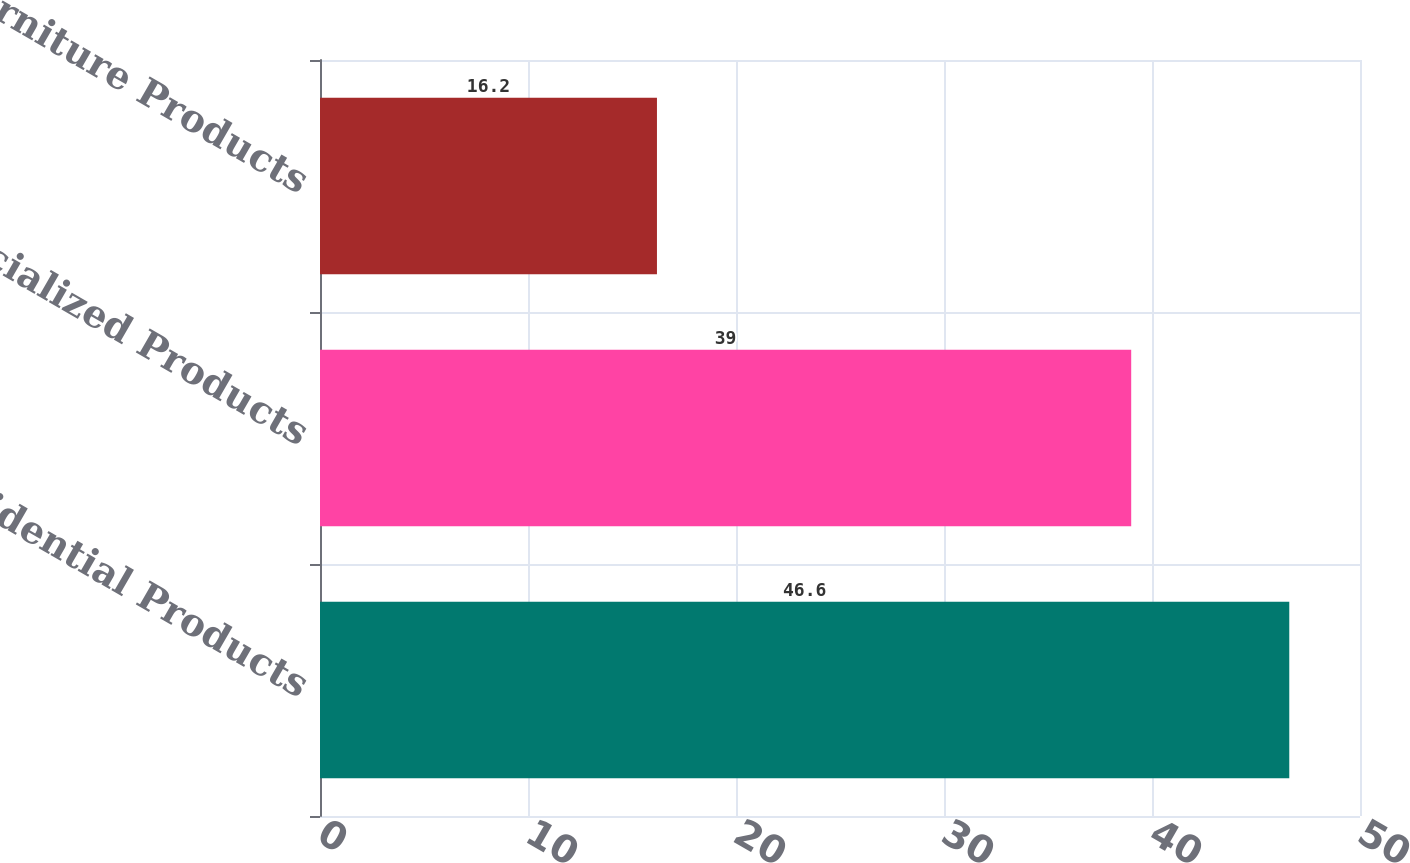Convert chart to OTSL. <chart><loc_0><loc_0><loc_500><loc_500><bar_chart><fcel>Residential Products<fcel>Specialized Products<fcel>Furniture Products<nl><fcel>46.6<fcel>39<fcel>16.2<nl></chart> 